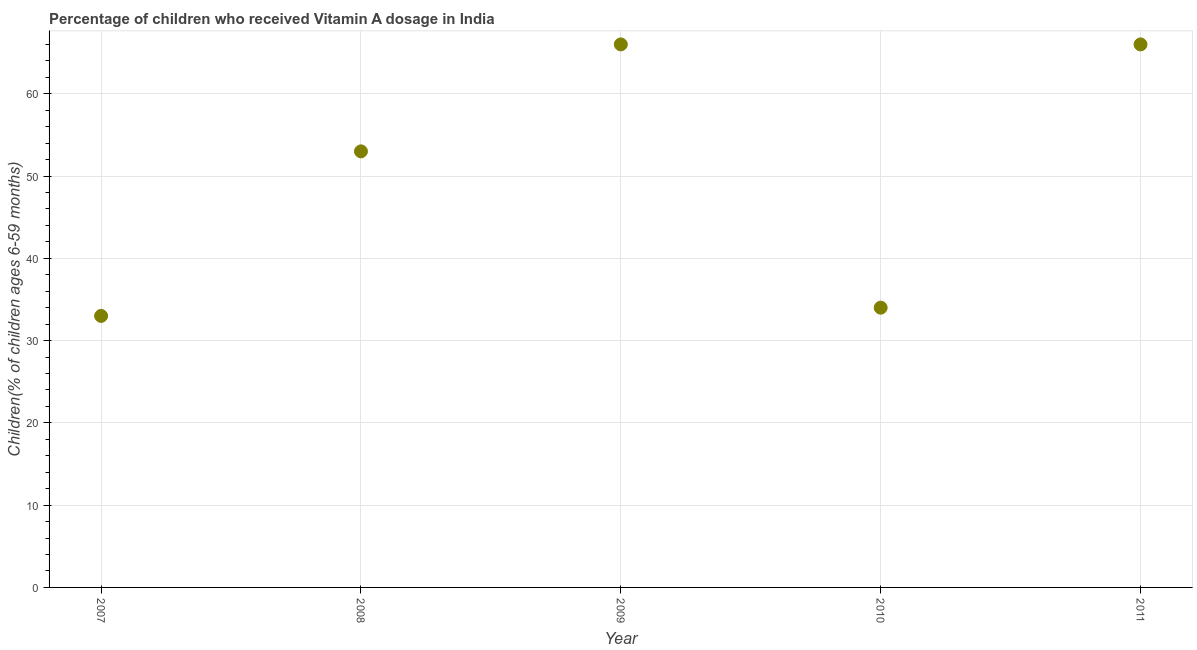What is the vitamin a supplementation coverage rate in 2011?
Provide a short and direct response. 66. Across all years, what is the maximum vitamin a supplementation coverage rate?
Give a very brief answer. 66. Across all years, what is the minimum vitamin a supplementation coverage rate?
Make the answer very short. 33. What is the sum of the vitamin a supplementation coverage rate?
Provide a succinct answer. 252. What is the difference between the vitamin a supplementation coverage rate in 2009 and 2010?
Offer a terse response. 32. What is the average vitamin a supplementation coverage rate per year?
Give a very brief answer. 50.4. What is the ratio of the vitamin a supplementation coverage rate in 2009 to that in 2010?
Your response must be concise. 1.94. Is the vitamin a supplementation coverage rate in 2009 less than that in 2011?
Make the answer very short. No. Is the difference between the vitamin a supplementation coverage rate in 2007 and 2008 greater than the difference between any two years?
Your response must be concise. No. What is the difference between the highest and the lowest vitamin a supplementation coverage rate?
Ensure brevity in your answer.  33. In how many years, is the vitamin a supplementation coverage rate greater than the average vitamin a supplementation coverage rate taken over all years?
Keep it short and to the point. 3. What is the difference between two consecutive major ticks on the Y-axis?
Ensure brevity in your answer.  10. Are the values on the major ticks of Y-axis written in scientific E-notation?
Give a very brief answer. No. Does the graph contain any zero values?
Provide a succinct answer. No. What is the title of the graph?
Provide a succinct answer. Percentage of children who received Vitamin A dosage in India. What is the label or title of the Y-axis?
Offer a terse response. Children(% of children ages 6-59 months). What is the Children(% of children ages 6-59 months) in 2008?
Offer a very short reply. 53. What is the Children(% of children ages 6-59 months) in 2009?
Offer a very short reply. 66. What is the difference between the Children(% of children ages 6-59 months) in 2007 and 2008?
Your answer should be very brief. -20. What is the difference between the Children(% of children ages 6-59 months) in 2007 and 2009?
Keep it short and to the point. -33. What is the difference between the Children(% of children ages 6-59 months) in 2007 and 2011?
Give a very brief answer. -33. What is the difference between the Children(% of children ages 6-59 months) in 2008 and 2009?
Provide a short and direct response. -13. What is the difference between the Children(% of children ages 6-59 months) in 2008 and 2010?
Give a very brief answer. 19. What is the difference between the Children(% of children ages 6-59 months) in 2010 and 2011?
Provide a short and direct response. -32. What is the ratio of the Children(% of children ages 6-59 months) in 2007 to that in 2008?
Offer a very short reply. 0.62. What is the ratio of the Children(% of children ages 6-59 months) in 2007 to that in 2009?
Your response must be concise. 0.5. What is the ratio of the Children(% of children ages 6-59 months) in 2007 to that in 2010?
Give a very brief answer. 0.97. What is the ratio of the Children(% of children ages 6-59 months) in 2007 to that in 2011?
Offer a terse response. 0.5. What is the ratio of the Children(% of children ages 6-59 months) in 2008 to that in 2009?
Offer a very short reply. 0.8. What is the ratio of the Children(% of children ages 6-59 months) in 2008 to that in 2010?
Make the answer very short. 1.56. What is the ratio of the Children(% of children ages 6-59 months) in 2008 to that in 2011?
Provide a short and direct response. 0.8. What is the ratio of the Children(% of children ages 6-59 months) in 2009 to that in 2010?
Your answer should be compact. 1.94. What is the ratio of the Children(% of children ages 6-59 months) in 2009 to that in 2011?
Provide a succinct answer. 1. What is the ratio of the Children(% of children ages 6-59 months) in 2010 to that in 2011?
Ensure brevity in your answer.  0.52. 